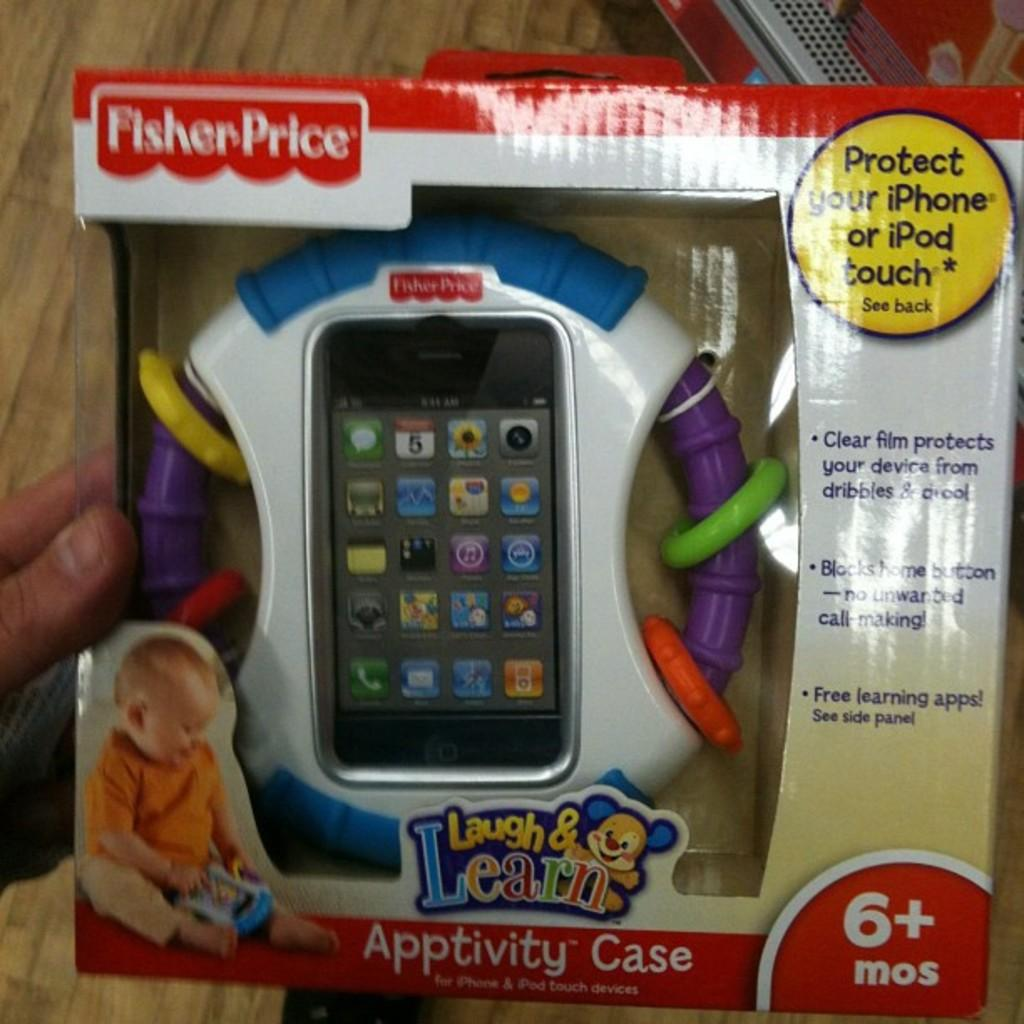Provide a one-sentence caption for the provided image. a children's toy from the company laugh and learn. 